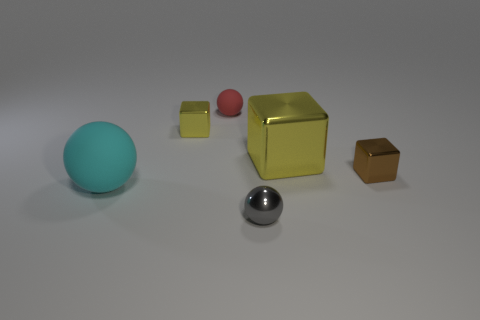Subtract all cyan matte balls. How many balls are left? 2 Subtract all cyan balls. How many balls are left? 2 Subtract all blue balls. How many yellow cubes are left? 2 Add 4 green metal spheres. How many objects exist? 10 Subtract all green cubes. Subtract all yellow spheres. How many cubes are left? 3 Add 1 big purple metallic objects. How many big purple metallic objects exist? 1 Subtract 0 green balls. How many objects are left? 6 Subtract 1 blocks. How many blocks are left? 2 Subtract all small yellow shiny blocks. Subtract all cyan objects. How many objects are left? 4 Add 4 matte spheres. How many matte spheres are left? 6 